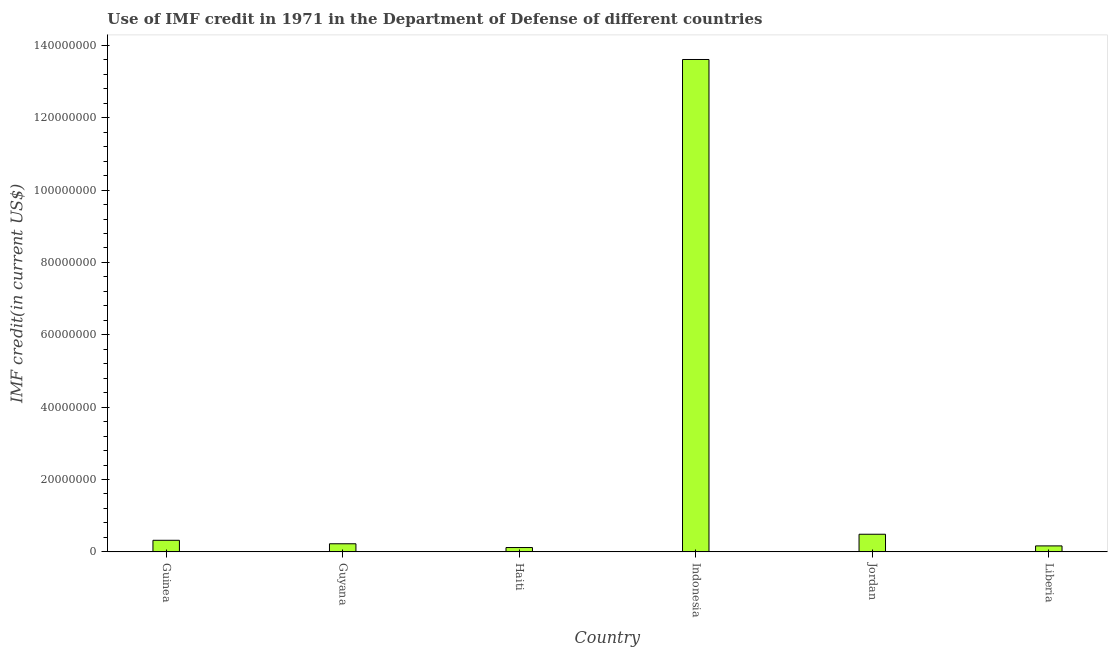Does the graph contain grids?
Your answer should be compact. No. What is the title of the graph?
Provide a short and direct response. Use of IMF credit in 1971 in the Department of Defense of different countries. What is the label or title of the X-axis?
Make the answer very short. Country. What is the label or title of the Y-axis?
Offer a terse response. IMF credit(in current US$). What is the use of imf credit in dod in Guyana?
Offer a very short reply. 2.24e+06. Across all countries, what is the maximum use of imf credit in dod?
Your answer should be compact. 1.36e+08. Across all countries, what is the minimum use of imf credit in dod?
Provide a short and direct response. 1.20e+06. In which country was the use of imf credit in dod minimum?
Make the answer very short. Haiti. What is the sum of the use of imf credit in dod?
Your answer should be compact. 1.49e+08. What is the difference between the use of imf credit in dod in Guyana and Jordan?
Make the answer very short. -2.64e+06. What is the average use of imf credit in dod per country?
Offer a terse response. 2.49e+07. What is the median use of imf credit in dod?
Give a very brief answer. 2.72e+06. In how many countries, is the use of imf credit in dod greater than 80000000 US$?
Provide a succinct answer. 1. What is the ratio of the use of imf credit in dod in Guyana to that in Liberia?
Ensure brevity in your answer.  1.36. Is the difference between the use of imf credit in dod in Guinea and Haiti greater than the difference between any two countries?
Give a very brief answer. No. What is the difference between the highest and the second highest use of imf credit in dod?
Keep it short and to the point. 1.31e+08. What is the difference between the highest and the lowest use of imf credit in dod?
Ensure brevity in your answer.  1.35e+08. How many bars are there?
Keep it short and to the point. 6. What is the difference between two consecutive major ticks on the Y-axis?
Offer a terse response. 2.00e+07. Are the values on the major ticks of Y-axis written in scientific E-notation?
Your answer should be very brief. No. What is the IMF credit(in current US$) in Guinea?
Provide a succinct answer. 3.20e+06. What is the IMF credit(in current US$) in Guyana?
Ensure brevity in your answer.  2.24e+06. What is the IMF credit(in current US$) of Haiti?
Give a very brief answer. 1.20e+06. What is the IMF credit(in current US$) in Indonesia?
Make the answer very short. 1.36e+08. What is the IMF credit(in current US$) in Jordan?
Your response must be concise. 4.87e+06. What is the IMF credit(in current US$) of Liberia?
Your answer should be compact. 1.65e+06. What is the difference between the IMF credit(in current US$) in Guinea and Guyana?
Your answer should be very brief. 9.66e+05. What is the difference between the IMF credit(in current US$) in Guinea and Haiti?
Your answer should be compact. 2.00e+06. What is the difference between the IMF credit(in current US$) in Guinea and Indonesia?
Provide a short and direct response. -1.33e+08. What is the difference between the IMF credit(in current US$) in Guinea and Jordan?
Give a very brief answer. -1.67e+06. What is the difference between the IMF credit(in current US$) in Guinea and Liberia?
Make the answer very short. 1.55e+06. What is the difference between the IMF credit(in current US$) in Guyana and Haiti?
Your answer should be compact. 1.04e+06. What is the difference between the IMF credit(in current US$) in Guyana and Indonesia?
Give a very brief answer. -1.34e+08. What is the difference between the IMF credit(in current US$) in Guyana and Jordan?
Your answer should be very brief. -2.64e+06. What is the difference between the IMF credit(in current US$) in Guyana and Liberia?
Your answer should be compact. 5.87e+05. What is the difference between the IMF credit(in current US$) in Haiti and Indonesia?
Offer a terse response. -1.35e+08. What is the difference between the IMF credit(in current US$) in Haiti and Jordan?
Offer a terse response. -3.67e+06. What is the difference between the IMF credit(in current US$) in Haiti and Liberia?
Your answer should be compact. -4.50e+05. What is the difference between the IMF credit(in current US$) in Indonesia and Jordan?
Your answer should be very brief. 1.31e+08. What is the difference between the IMF credit(in current US$) in Indonesia and Liberia?
Provide a succinct answer. 1.34e+08. What is the difference between the IMF credit(in current US$) in Jordan and Liberia?
Offer a terse response. 3.22e+06. What is the ratio of the IMF credit(in current US$) in Guinea to that in Guyana?
Your answer should be very brief. 1.43. What is the ratio of the IMF credit(in current US$) in Guinea to that in Haiti?
Make the answer very short. 2.67. What is the ratio of the IMF credit(in current US$) in Guinea to that in Indonesia?
Ensure brevity in your answer.  0.02. What is the ratio of the IMF credit(in current US$) in Guinea to that in Jordan?
Your answer should be compact. 0.66. What is the ratio of the IMF credit(in current US$) in Guinea to that in Liberia?
Provide a short and direct response. 1.94. What is the ratio of the IMF credit(in current US$) in Guyana to that in Haiti?
Offer a terse response. 1.86. What is the ratio of the IMF credit(in current US$) in Guyana to that in Indonesia?
Your answer should be compact. 0.02. What is the ratio of the IMF credit(in current US$) in Guyana to that in Jordan?
Offer a very short reply. 0.46. What is the ratio of the IMF credit(in current US$) in Guyana to that in Liberia?
Give a very brief answer. 1.36. What is the ratio of the IMF credit(in current US$) in Haiti to that in Indonesia?
Your answer should be compact. 0.01. What is the ratio of the IMF credit(in current US$) in Haiti to that in Jordan?
Your answer should be compact. 0.25. What is the ratio of the IMF credit(in current US$) in Haiti to that in Liberia?
Offer a terse response. 0.73. What is the ratio of the IMF credit(in current US$) in Indonesia to that in Jordan?
Give a very brief answer. 27.92. What is the ratio of the IMF credit(in current US$) in Indonesia to that in Liberia?
Your response must be concise. 82.48. What is the ratio of the IMF credit(in current US$) in Jordan to that in Liberia?
Your answer should be compact. 2.95. 